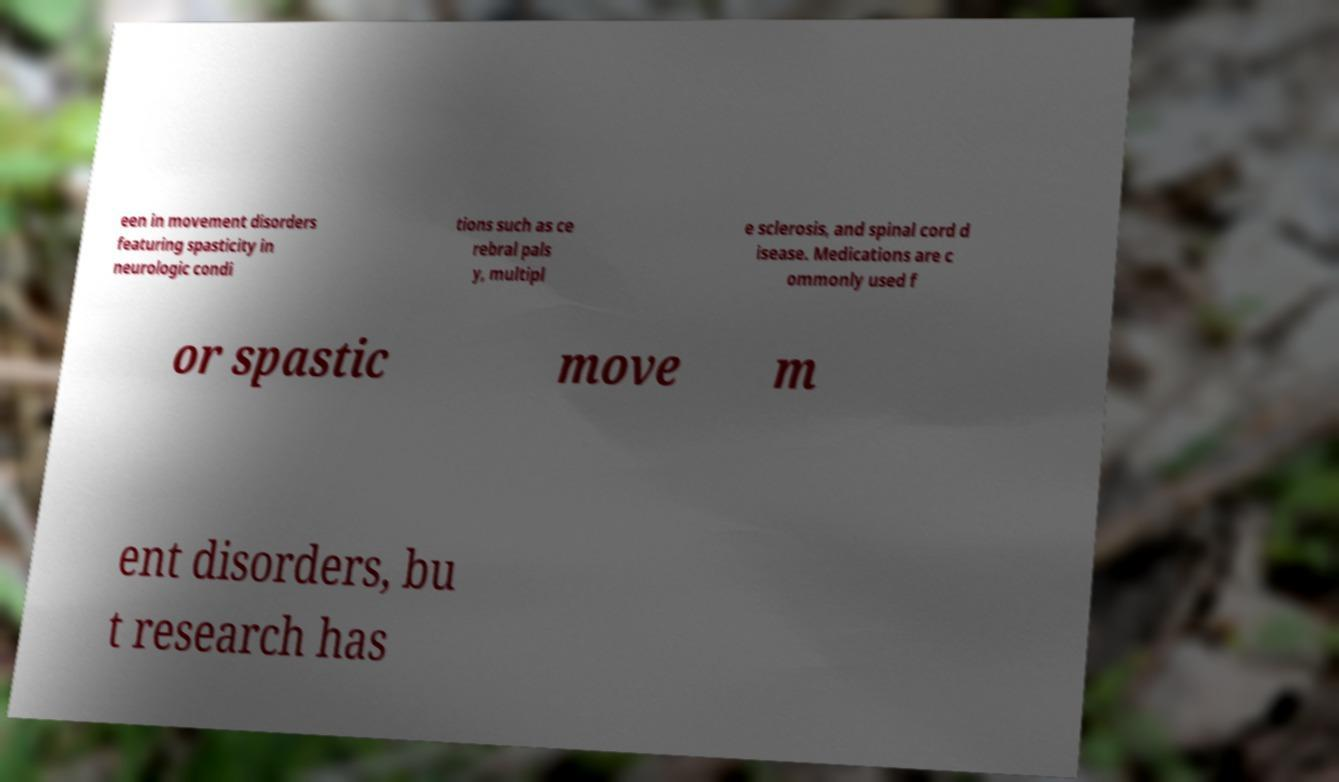I need the written content from this picture converted into text. Can you do that? een in movement disorders featuring spasticity in neurologic condi tions such as ce rebral pals y, multipl e sclerosis, and spinal cord d isease. Medications are c ommonly used f or spastic move m ent disorders, bu t research has 